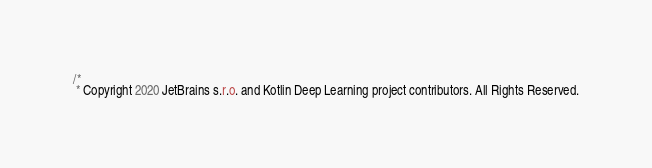<code> <loc_0><loc_0><loc_500><loc_500><_Kotlin_>/*
 * Copyright 2020 JetBrains s.r.o. and Kotlin Deep Learning project contributors. All Rights Reserved.</code> 